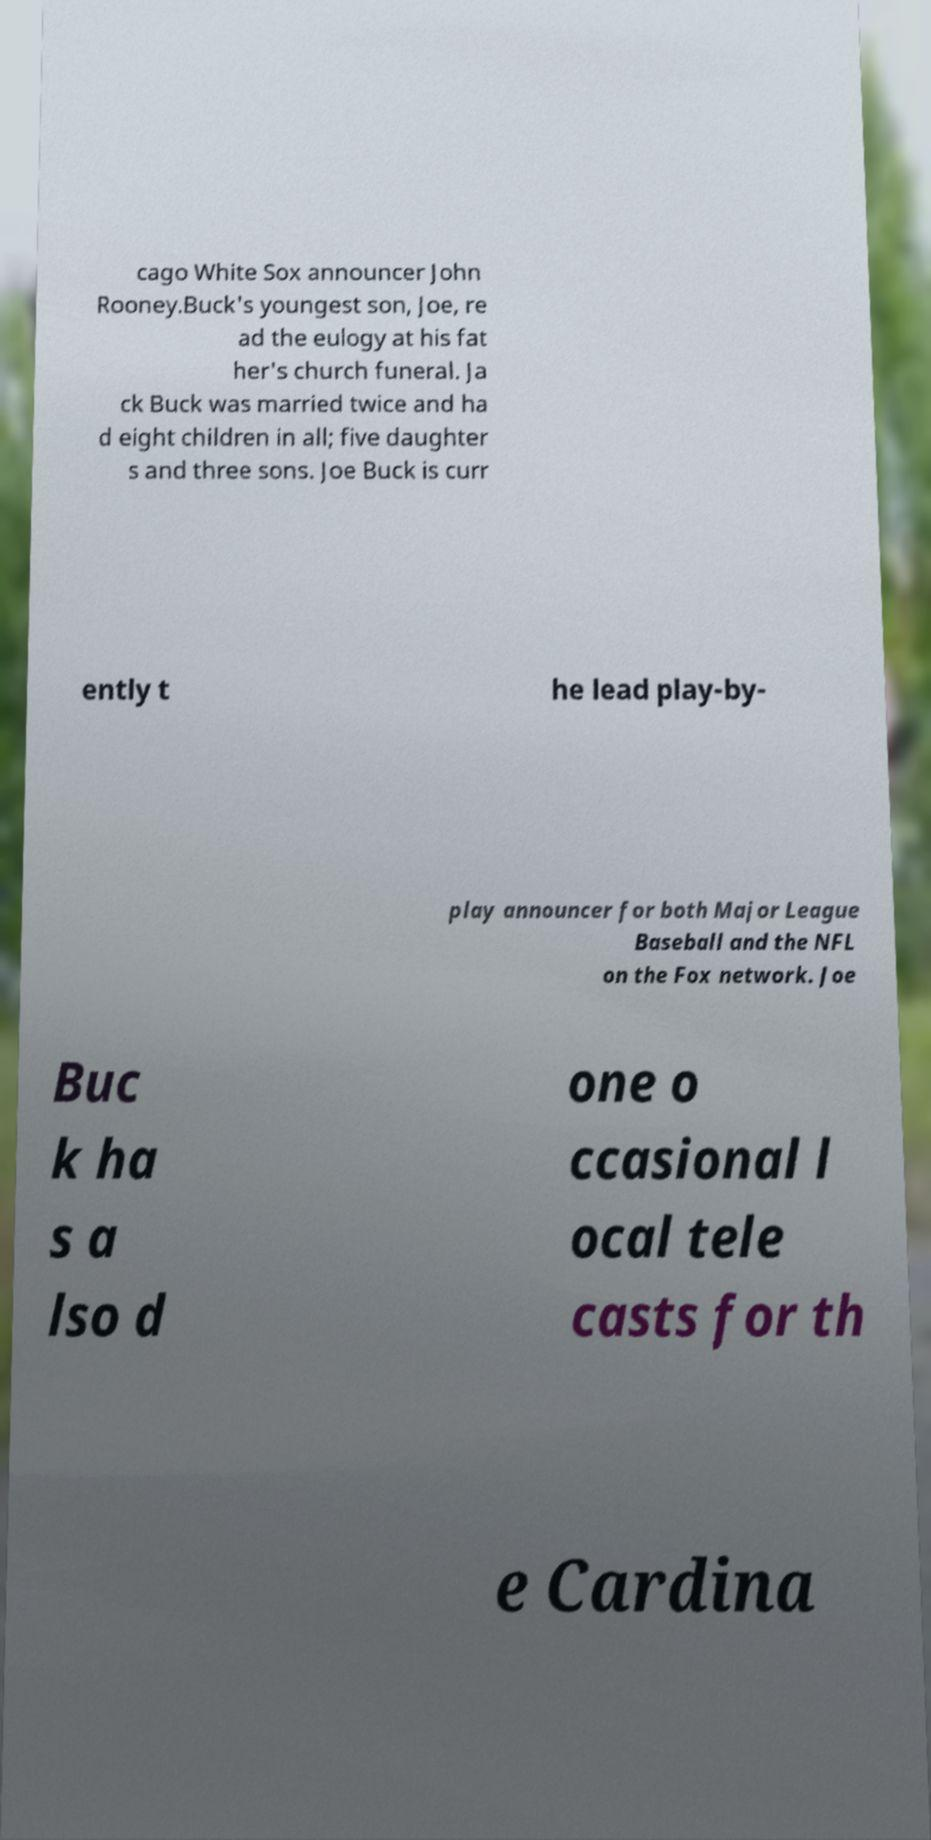What messages or text are displayed in this image? I need them in a readable, typed format. cago White Sox announcer John Rooney.Buck's youngest son, Joe, re ad the eulogy at his fat her's church funeral. Ja ck Buck was married twice and ha d eight children in all; five daughter s and three sons. Joe Buck is curr ently t he lead play-by- play announcer for both Major League Baseball and the NFL on the Fox network. Joe Buc k ha s a lso d one o ccasional l ocal tele casts for th e Cardina 